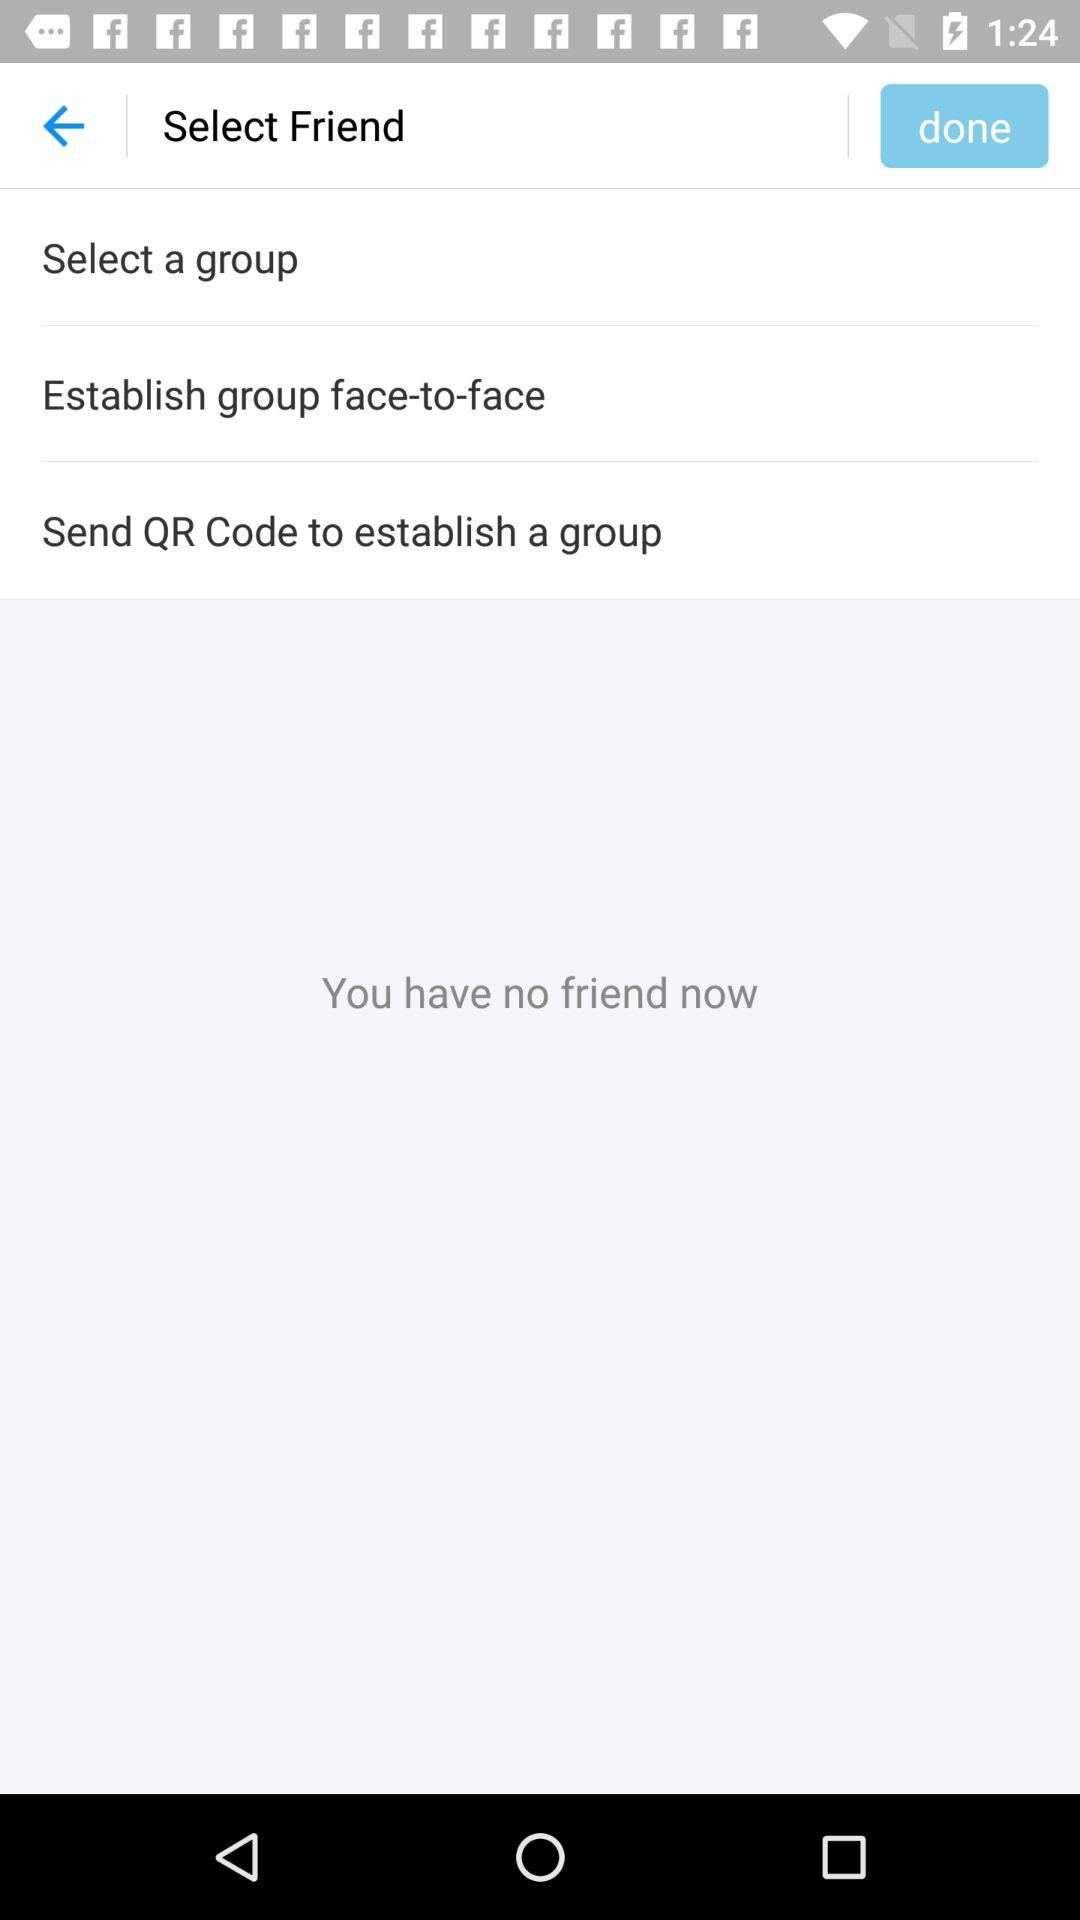How many friends do I have?
Answer the question using a single word or phrase. 0 